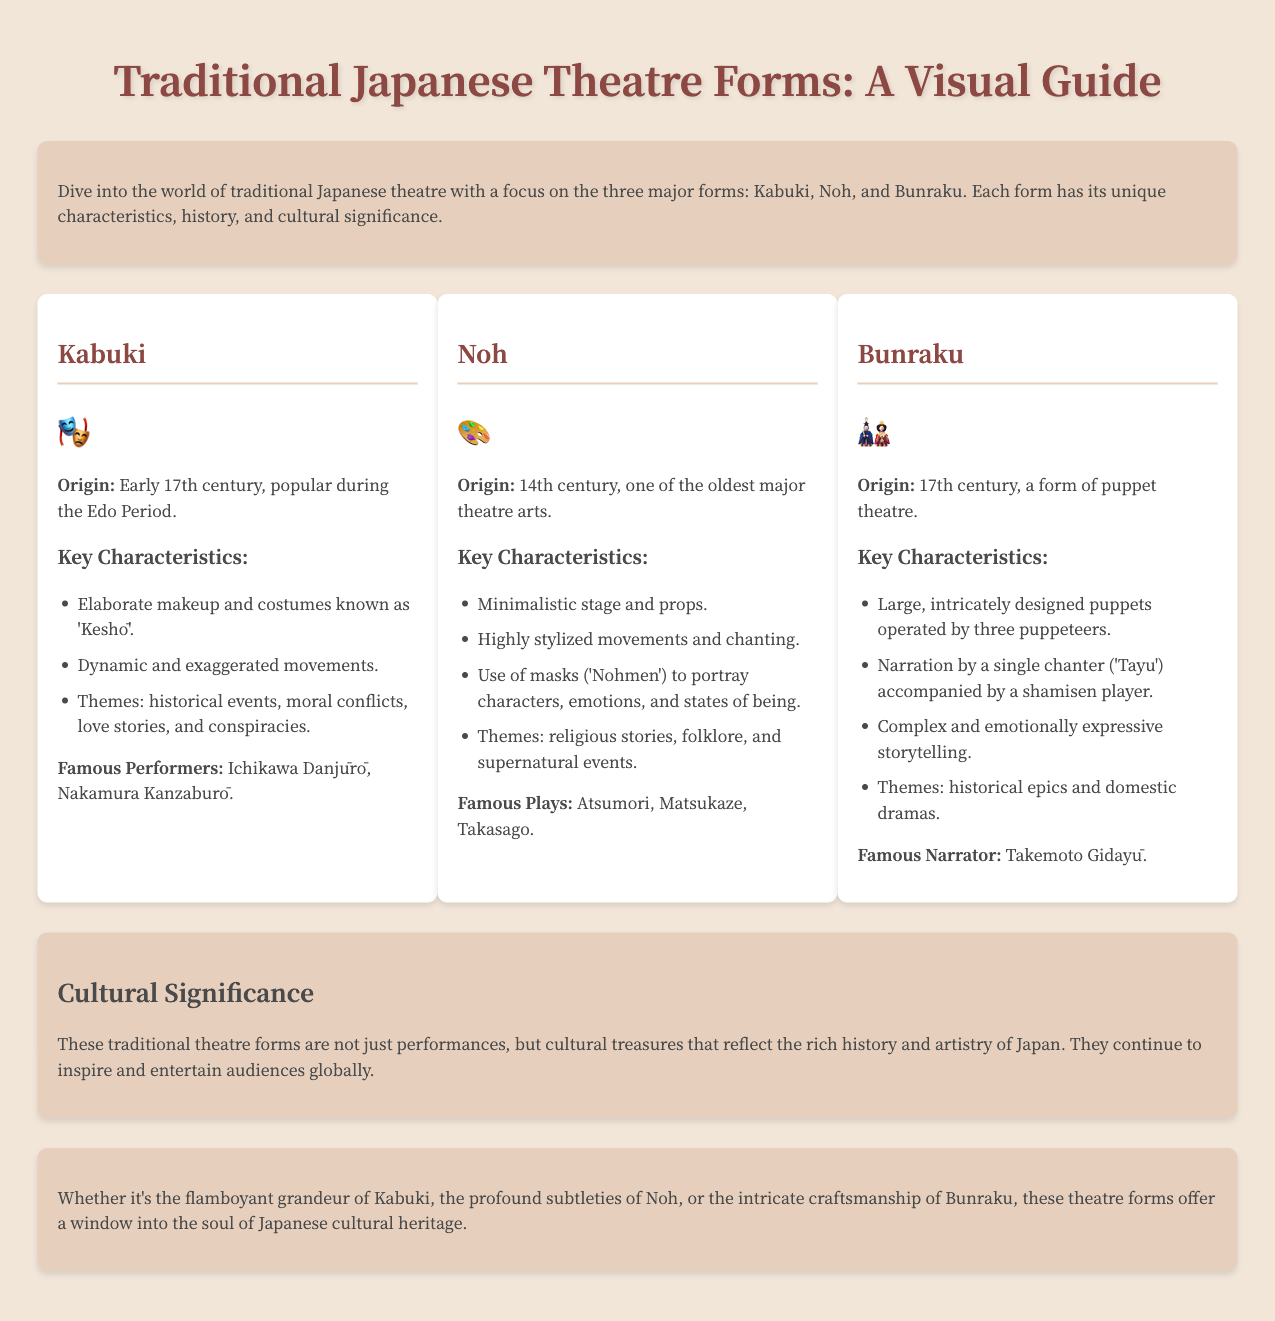What is the origin of Kabuki? The document states that Kabuki originated in the early 17th century.
Answer: Early 17th century What themes are explored in Noh theatre? The document lists the themes of Noh theatre as religious stories, folklore, and supernatural events.
Answer: Religious stories, folklore, and supernatural events Who is a famous performer of Kabuki? A famous performer mentioned in the document is Ichikawa Danjūrō.
Answer: Ichikawa Danjūrō What is the unique feature of Bunraku puppets? The document states that Bunraku features large, intricately designed puppets operated by three puppeteers.
Answer: Operated by three puppeteers What is the cultural significance of these theatre forms? The document explains that these theatre forms are cultural treasures reflecting Japan's rich history and artistry.
Answer: Cultural treasures How many types of traditional Japanese theatre are discussed? The document discusses three major forms of traditional Japanese theatre.
Answer: Three What kind of stage is used in Noh theatre? The document describes the Noh theatre stage as minimalistic.
Answer: Minimalistic Who provides the narration in Bunraku? According to the document, the narration in Bunraku is provided by a single chanter known as Tayu.
Answer: Tayu 